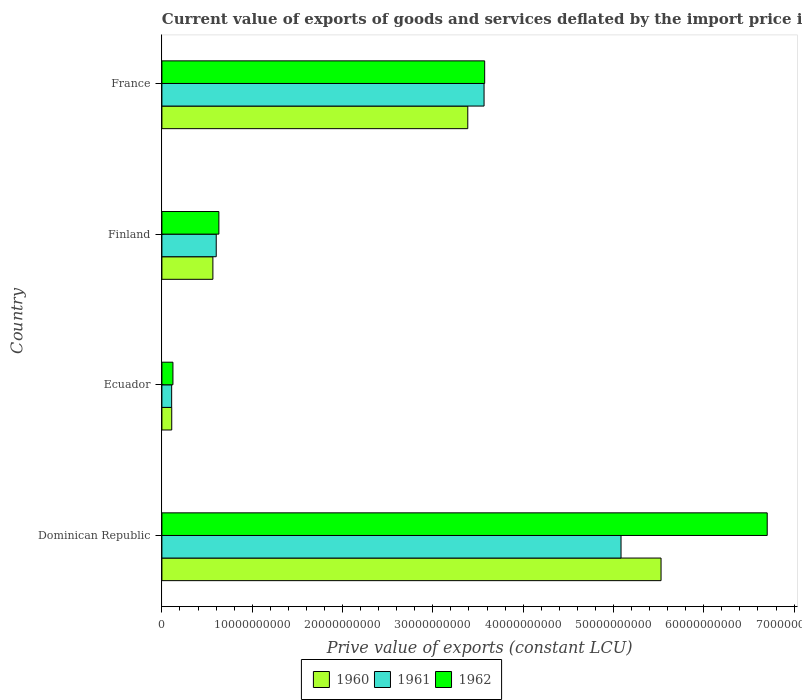How many groups of bars are there?
Give a very brief answer. 4. Are the number of bars per tick equal to the number of legend labels?
Ensure brevity in your answer.  Yes. Are the number of bars on each tick of the Y-axis equal?
Keep it short and to the point. Yes. What is the prive value of exports in 1962 in Finland?
Offer a terse response. 6.31e+09. Across all countries, what is the maximum prive value of exports in 1960?
Your response must be concise. 5.53e+1. Across all countries, what is the minimum prive value of exports in 1962?
Your answer should be very brief. 1.22e+09. In which country was the prive value of exports in 1961 maximum?
Offer a terse response. Dominican Republic. In which country was the prive value of exports in 1960 minimum?
Provide a short and direct response. Ecuador. What is the total prive value of exports in 1961 in the graph?
Ensure brevity in your answer.  9.36e+1. What is the difference between the prive value of exports in 1960 in Dominican Republic and that in Finland?
Your response must be concise. 4.96e+1. What is the difference between the prive value of exports in 1962 in Dominican Republic and the prive value of exports in 1960 in Ecuador?
Give a very brief answer. 6.59e+1. What is the average prive value of exports in 1961 per country?
Offer a very short reply. 2.34e+1. What is the difference between the prive value of exports in 1961 and prive value of exports in 1962 in Dominican Republic?
Provide a succinct answer. -1.62e+1. What is the ratio of the prive value of exports in 1962 in Dominican Republic to that in Finland?
Your answer should be very brief. 10.62. What is the difference between the highest and the second highest prive value of exports in 1962?
Keep it short and to the point. 3.13e+1. What is the difference between the highest and the lowest prive value of exports in 1961?
Give a very brief answer. 4.98e+1. What does the 3rd bar from the top in Finland represents?
Offer a terse response. 1960. Are all the bars in the graph horizontal?
Provide a short and direct response. Yes. Are the values on the major ticks of X-axis written in scientific E-notation?
Your answer should be very brief. No. What is the title of the graph?
Offer a terse response. Current value of exports of goods and services deflated by the import price index. What is the label or title of the X-axis?
Give a very brief answer. Prive value of exports (constant LCU). What is the Prive value of exports (constant LCU) in 1960 in Dominican Republic?
Offer a terse response. 5.53e+1. What is the Prive value of exports (constant LCU) of 1961 in Dominican Republic?
Offer a very short reply. 5.08e+1. What is the Prive value of exports (constant LCU) of 1962 in Dominican Republic?
Provide a short and direct response. 6.70e+1. What is the Prive value of exports (constant LCU) of 1960 in Ecuador?
Provide a short and direct response. 1.09e+09. What is the Prive value of exports (constant LCU) in 1961 in Ecuador?
Provide a succinct answer. 1.08e+09. What is the Prive value of exports (constant LCU) of 1962 in Ecuador?
Your answer should be compact. 1.22e+09. What is the Prive value of exports (constant LCU) of 1960 in Finland?
Keep it short and to the point. 5.65e+09. What is the Prive value of exports (constant LCU) of 1961 in Finland?
Provide a short and direct response. 6.02e+09. What is the Prive value of exports (constant LCU) in 1962 in Finland?
Make the answer very short. 6.31e+09. What is the Prive value of exports (constant LCU) in 1960 in France?
Your answer should be compact. 3.39e+1. What is the Prive value of exports (constant LCU) of 1961 in France?
Provide a short and direct response. 3.57e+1. What is the Prive value of exports (constant LCU) in 1962 in France?
Your response must be concise. 3.57e+1. Across all countries, what is the maximum Prive value of exports (constant LCU) of 1960?
Ensure brevity in your answer.  5.53e+1. Across all countries, what is the maximum Prive value of exports (constant LCU) in 1961?
Offer a terse response. 5.08e+1. Across all countries, what is the maximum Prive value of exports (constant LCU) of 1962?
Provide a short and direct response. 6.70e+1. Across all countries, what is the minimum Prive value of exports (constant LCU) of 1960?
Provide a succinct answer. 1.09e+09. Across all countries, what is the minimum Prive value of exports (constant LCU) of 1961?
Your answer should be very brief. 1.08e+09. Across all countries, what is the minimum Prive value of exports (constant LCU) in 1962?
Give a very brief answer. 1.22e+09. What is the total Prive value of exports (constant LCU) of 1960 in the graph?
Provide a succinct answer. 9.59e+1. What is the total Prive value of exports (constant LCU) in 1961 in the graph?
Your answer should be compact. 9.36e+1. What is the total Prive value of exports (constant LCU) of 1962 in the graph?
Give a very brief answer. 1.10e+11. What is the difference between the Prive value of exports (constant LCU) of 1960 in Dominican Republic and that in Ecuador?
Provide a short and direct response. 5.42e+1. What is the difference between the Prive value of exports (constant LCU) of 1961 in Dominican Republic and that in Ecuador?
Offer a very short reply. 4.98e+1. What is the difference between the Prive value of exports (constant LCU) of 1962 in Dominican Republic and that in Ecuador?
Your response must be concise. 6.58e+1. What is the difference between the Prive value of exports (constant LCU) in 1960 in Dominican Republic and that in Finland?
Ensure brevity in your answer.  4.96e+1. What is the difference between the Prive value of exports (constant LCU) of 1961 in Dominican Republic and that in Finland?
Your answer should be compact. 4.48e+1. What is the difference between the Prive value of exports (constant LCU) of 1962 in Dominican Republic and that in Finland?
Offer a terse response. 6.07e+1. What is the difference between the Prive value of exports (constant LCU) in 1960 in Dominican Republic and that in France?
Offer a very short reply. 2.14e+1. What is the difference between the Prive value of exports (constant LCU) in 1961 in Dominican Republic and that in France?
Ensure brevity in your answer.  1.52e+1. What is the difference between the Prive value of exports (constant LCU) in 1962 in Dominican Republic and that in France?
Offer a very short reply. 3.13e+1. What is the difference between the Prive value of exports (constant LCU) in 1960 in Ecuador and that in Finland?
Give a very brief answer. -4.56e+09. What is the difference between the Prive value of exports (constant LCU) of 1961 in Ecuador and that in Finland?
Your answer should be compact. -4.94e+09. What is the difference between the Prive value of exports (constant LCU) in 1962 in Ecuador and that in Finland?
Your answer should be compact. -5.09e+09. What is the difference between the Prive value of exports (constant LCU) in 1960 in Ecuador and that in France?
Your answer should be very brief. -3.28e+1. What is the difference between the Prive value of exports (constant LCU) of 1961 in Ecuador and that in France?
Ensure brevity in your answer.  -3.46e+1. What is the difference between the Prive value of exports (constant LCU) in 1962 in Ecuador and that in France?
Your answer should be compact. -3.45e+1. What is the difference between the Prive value of exports (constant LCU) of 1960 in Finland and that in France?
Provide a short and direct response. -2.82e+1. What is the difference between the Prive value of exports (constant LCU) in 1961 in Finland and that in France?
Ensure brevity in your answer.  -2.97e+1. What is the difference between the Prive value of exports (constant LCU) in 1962 in Finland and that in France?
Make the answer very short. -2.94e+1. What is the difference between the Prive value of exports (constant LCU) in 1960 in Dominican Republic and the Prive value of exports (constant LCU) in 1961 in Ecuador?
Ensure brevity in your answer.  5.42e+1. What is the difference between the Prive value of exports (constant LCU) of 1960 in Dominican Republic and the Prive value of exports (constant LCU) of 1962 in Ecuador?
Give a very brief answer. 5.40e+1. What is the difference between the Prive value of exports (constant LCU) in 1961 in Dominican Republic and the Prive value of exports (constant LCU) in 1962 in Ecuador?
Provide a succinct answer. 4.96e+1. What is the difference between the Prive value of exports (constant LCU) in 1960 in Dominican Republic and the Prive value of exports (constant LCU) in 1961 in Finland?
Offer a very short reply. 4.93e+1. What is the difference between the Prive value of exports (constant LCU) in 1960 in Dominican Republic and the Prive value of exports (constant LCU) in 1962 in Finland?
Provide a succinct answer. 4.90e+1. What is the difference between the Prive value of exports (constant LCU) in 1961 in Dominican Republic and the Prive value of exports (constant LCU) in 1962 in Finland?
Your answer should be compact. 4.45e+1. What is the difference between the Prive value of exports (constant LCU) in 1960 in Dominican Republic and the Prive value of exports (constant LCU) in 1961 in France?
Give a very brief answer. 1.96e+1. What is the difference between the Prive value of exports (constant LCU) in 1960 in Dominican Republic and the Prive value of exports (constant LCU) in 1962 in France?
Your answer should be very brief. 1.95e+1. What is the difference between the Prive value of exports (constant LCU) of 1961 in Dominican Republic and the Prive value of exports (constant LCU) of 1962 in France?
Ensure brevity in your answer.  1.51e+1. What is the difference between the Prive value of exports (constant LCU) in 1960 in Ecuador and the Prive value of exports (constant LCU) in 1961 in Finland?
Make the answer very short. -4.93e+09. What is the difference between the Prive value of exports (constant LCU) of 1960 in Ecuador and the Prive value of exports (constant LCU) of 1962 in Finland?
Your response must be concise. -5.22e+09. What is the difference between the Prive value of exports (constant LCU) in 1961 in Ecuador and the Prive value of exports (constant LCU) in 1962 in Finland?
Make the answer very short. -5.23e+09. What is the difference between the Prive value of exports (constant LCU) of 1960 in Ecuador and the Prive value of exports (constant LCU) of 1961 in France?
Offer a terse response. -3.46e+1. What is the difference between the Prive value of exports (constant LCU) in 1960 in Ecuador and the Prive value of exports (constant LCU) in 1962 in France?
Make the answer very short. -3.47e+1. What is the difference between the Prive value of exports (constant LCU) of 1961 in Ecuador and the Prive value of exports (constant LCU) of 1962 in France?
Offer a very short reply. -3.47e+1. What is the difference between the Prive value of exports (constant LCU) in 1960 in Finland and the Prive value of exports (constant LCU) in 1961 in France?
Your answer should be compact. -3.00e+1. What is the difference between the Prive value of exports (constant LCU) in 1960 in Finland and the Prive value of exports (constant LCU) in 1962 in France?
Your answer should be compact. -3.01e+1. What is the difference between the Prive value of exports (constant LCU) of 1961 in Finland and the Prive value of exports (constant LCU) of 1962 in France?
Your answer should be compact. -2.97e+1. What is the average Prive value of exports (constant LCU) of 1960 per country?
Give a very brief answer. 2.40e+1. What is the average Prive value of exports (constant LCU) in 1961 per country?
Provide a succinct answer. 2.34e+1. What is the average Prive value of exports (constant LCU) of 1962 per country?
Provide a succinct answer. 2.76e+1. What is the difference between the Prive value of exports (constant LCU) in 1960 and Prive value of exports (constant LCU) in 1961 in Dominican Republic?
Ensure brevity in your answer.  4.43e+09. What is the difference between the Prive value of exports (constant LCU) in 1960 and Prive value of exports (constant LCU) in 1962 in Dominican Republic?
Make the answer very short. -1.18e+1. What is the difference between the Prive value of exports (constant LCU) in 1961 and Prive value of exports (constant LCU) in 1962 in Dominican Republic?
Your answer should be compact. -1.62e+1. What is the difference between the Prive value of exports (constant LCU) of 1960 and Prive value of exports (constant LCU) of 1961 in Ecuador?
Make the answer very short. 7.73e+06. What is the difference between the Prive value of exports (constant LCU) in 1960 and Prive value of exports (constant LCU) in 1962 in Ecuador?
Ensure brevity in your answer.  -1.34e+08. What is the difference between the Prive value of exports (constant LCU) in 1961 and Prive value of exports (constant LCU) in 1962 in Ecuador?
Your answer should be compact. -1.41e+08. What is the difference between the Prive value of exports (constant LCU) of 1960 and Prive value of exports (constant LCU) of 1961 in Finland?
Your answer should be compact. -3.69e+08. What is the difference between the Prive value of exports (constant LCU) in 1960 and Prive value of exports (constant LCU) in 1962 in Finland?
Provide a succinct answer. -6.62e+08. What is the difference between the Prive value of exports (constant LCU) of 1961 and Prive value of exports (constant LCU) of 1962 in Finland?
Your answer should be very brief. -2.93e+08. What is the difference between the Prive value of exports (constant LCU) of 1960 and Prive value of exports (constant LCU) of 1961 in France?
Offer a terse response. -1.80e+09. What is the difference between the Prive value of exports (constant LCU) of 1960 and Prive value of exports (constant LCU) of 1962 in France?
Make the answer very short. -1.87e+09. What is the difference between the Prive value of exports (constant LCU) of 1961 and Prive value of exports (constant LCU) of 1962 in France?
Provide a succinct answer. -6.74e+07. What is the ratio of the Prive value of exports (constant LCU) of 1960 in Dominican Republic to that in Ecuador?
Offer a terse response. 50.79. What is the ratio of the Prive value of exports (constant LCU) in 1961 in Dominican Republic to that in Ecuador?
Give a very brief answer. 47.06. What is the ratio of the Prive value of exports (constant LCU) in 1962 in Dominican Republic to that in Ecuador?
Your response must be concise. 54.86. What is the ratio of the Prive value of exports (constant LCU) in 1960 in Dominican Republic to that in Finland?
Keep it short and to the point. 9.79. What is the ratio of the Prive value of exports (constant LCU) in 1961 in Dominican Republic to that in Finland?
Your answer should be compact. 8.45. What is the ratio of the Prive value of exports (constant LCU) in 1962 in Dominican Republic to that in Finland?
Offer a very short reply. 10.62. What is the ratio of the Prive value of exports (constant LCU) of 1960 in Dominican Republic to that in France?
Provide a succinct answer. 1.63. What is the ratio of the Prive value of exports (constant LCU) of 1961 in Dominican Republic to that in France?
Give a very brief answer. 1.43. What is the ratio of the Prive value of exports (constant LCU) in 1962 in Dominican Republic to that in France?
Make the answer very short. 1.88. What is the ratio of the Prive value of exports (constant LCU) of 1960 in Ecuador to that in Finland?
Make the answer very short. 0.19. What is the ratio of the Prive value of exports (constant LCU) of 1961 in Ecuador to that in Finland?
Offer a very short reply. 0.18. What is the ratio of the Prive value of exports (constant LCU) in 1962 in Ecuador to that in Finland?
Your answer should be compact. 0.19. What is the ratio of the Prive value of exports (constant LCU) in 1960 in Ecuador to that in France?
Give a very brief answer. 0.03. What is the ratio of the Prive value of exports (constant LCU) in 1961 in Ecuador to that in France?
Your answer should be very brief. 0.03. What is the ratio of the Prive value of exports (constant LCU) in 1962 in Ecuador to that in France?
Offer a terse response. 0.03. What is the ratio of the Prive value of exports (constant LCU) of 1961 in Finland to that in France?
Provide a short and direct response. 0.17. What is the ratio of the Prive value of exports (constant LCU) in 1962 in Finland to that in France?
Keep it short and to the point. 0.18. What is the difference between the highest and the second highest Prive value of exports (constant LCU) in 1960?
Give a very brief answer. 2.14e+1. What is the difference between the highest and the second highest Prive value of exports (constant LCU) of 1961?
Give a very brief answer. 1.52e+1. What is the difference between the highest and the second highest Prive value of exports (constant LCU) of 1962?
Your response must be concise. 3.13e+1. What is the difference between the highest and the lowest Prive value of exports (constant LCU) in 1960?
Provide a short and direct response. 5.42e+1. What is the difference between the highest and the lowest Prive value of exports (constant LCU) in 1961?
Provide a short and direct response. 4.98e+1. What is the difference between the highest and the lowest Prive value of exports (constant LCU) of 1962?
Provide a succinct answer. 6.58e+1. 